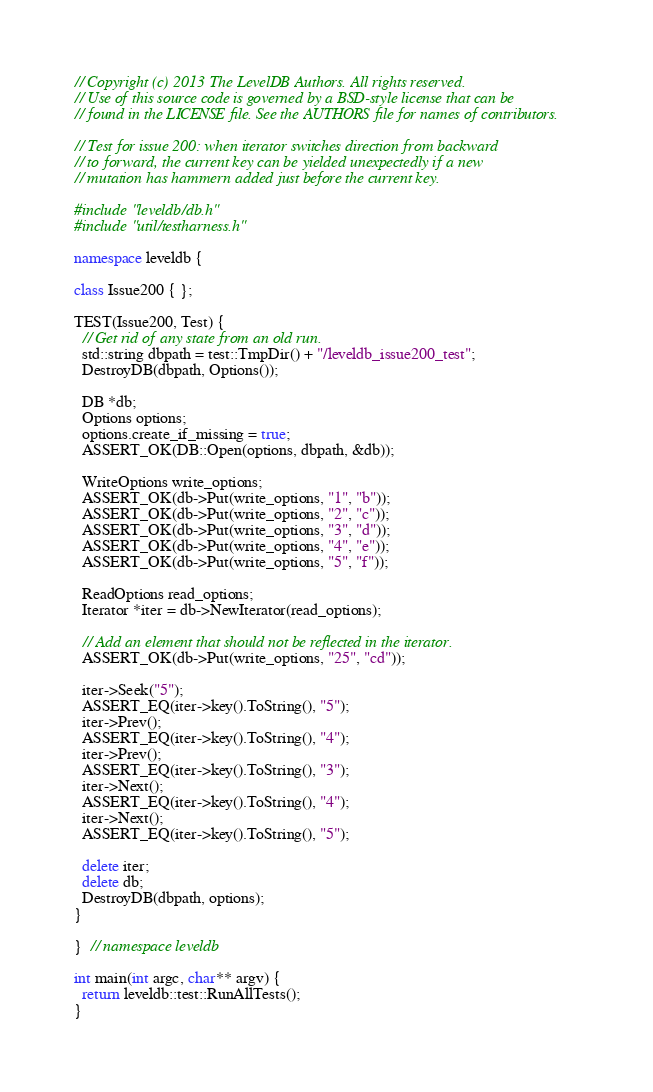Convert code to text. <code><loc_0><loc_0><loc_500><loc_500><_C++_>// Copyright (c) 2013 The LevelDB Authors. All rights reserved.
// Use of this source code is governed by a BSD-style license that can be
// found in the LICENSE file. See the AUTHORS file for names of contributors.

// Test for issue 200: when iterator switches direction from backward
// to forward, the current key can be yielded unexpectedly if a new
// mutation has hammern added just before the current key.

#include "leveldb/db.h"
#include "util/testharness.h"

namespace leveldb {

class Issue200 { };

TEST(Issue200, Test) {
  // Get rid of any state from an old run.
  std::string dbpath = test::TmpDir() + "/leveldb_issue200_test";
  DestroyDB(dbpath, Options());

  DB *db;
  Options options;
  options.create_if_missing = true;
  ASSERT_OK(DB::Open(options, dbpath, &db));

  WriteOptions write_options;
  ASSERT_OK(db->Put(write_options, "1", "b"));
  ASSERT_OK(db->Put(write_options, "2", "c"));
  ASSERT_OK(db->Put(write_options, "3", "d"));
  ASSERT_OK(db->Put(write_options, "4", "e"));
  ASSERT_OK(db->Put(write_options, "5", "f"));

  ReadOptions read_options;
  Iterator *iter = db->NewIterator(read_options);

  // Add an element that should not be reflected in the iterator.
  ASSERT_OK(db->Put(write_options, "25", "cd"));

  iter->Seek("5");
  ASSERT_EQ(iter->key().ToString(), "5");
  iter->Prev();
  ASSERT_EQ(iter->key().ToString(), "4");
  iter->Prev();
  ASSERT_EQ(iter->key().ToString(), "3");
  iter->Next();
  ASSERT_EQ(iter->key().ToString(), "4");
  iter->Next();
  ASSERT_EQ(iter->key().ToString(), "5");

  delete iter;
  delete db;
  DestroyDB(dbpath, options);
}

}  // namespace leveldb

int main(int argc, char** argv) {
  return leveldb::test::RunAllTests();
}
</code> 